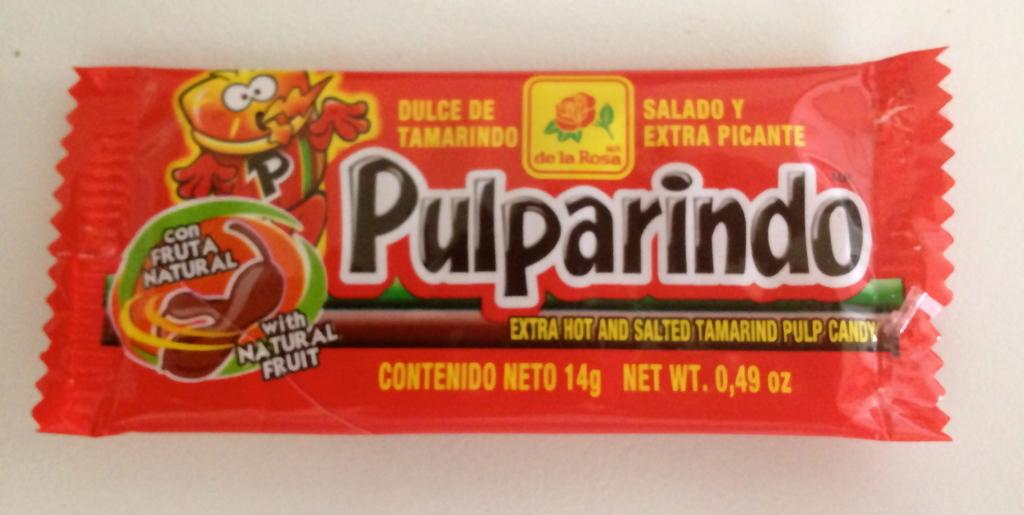<image>
Share a concise interpretation of the image provided. Red natural candy bar that is labeled Pulparindo 